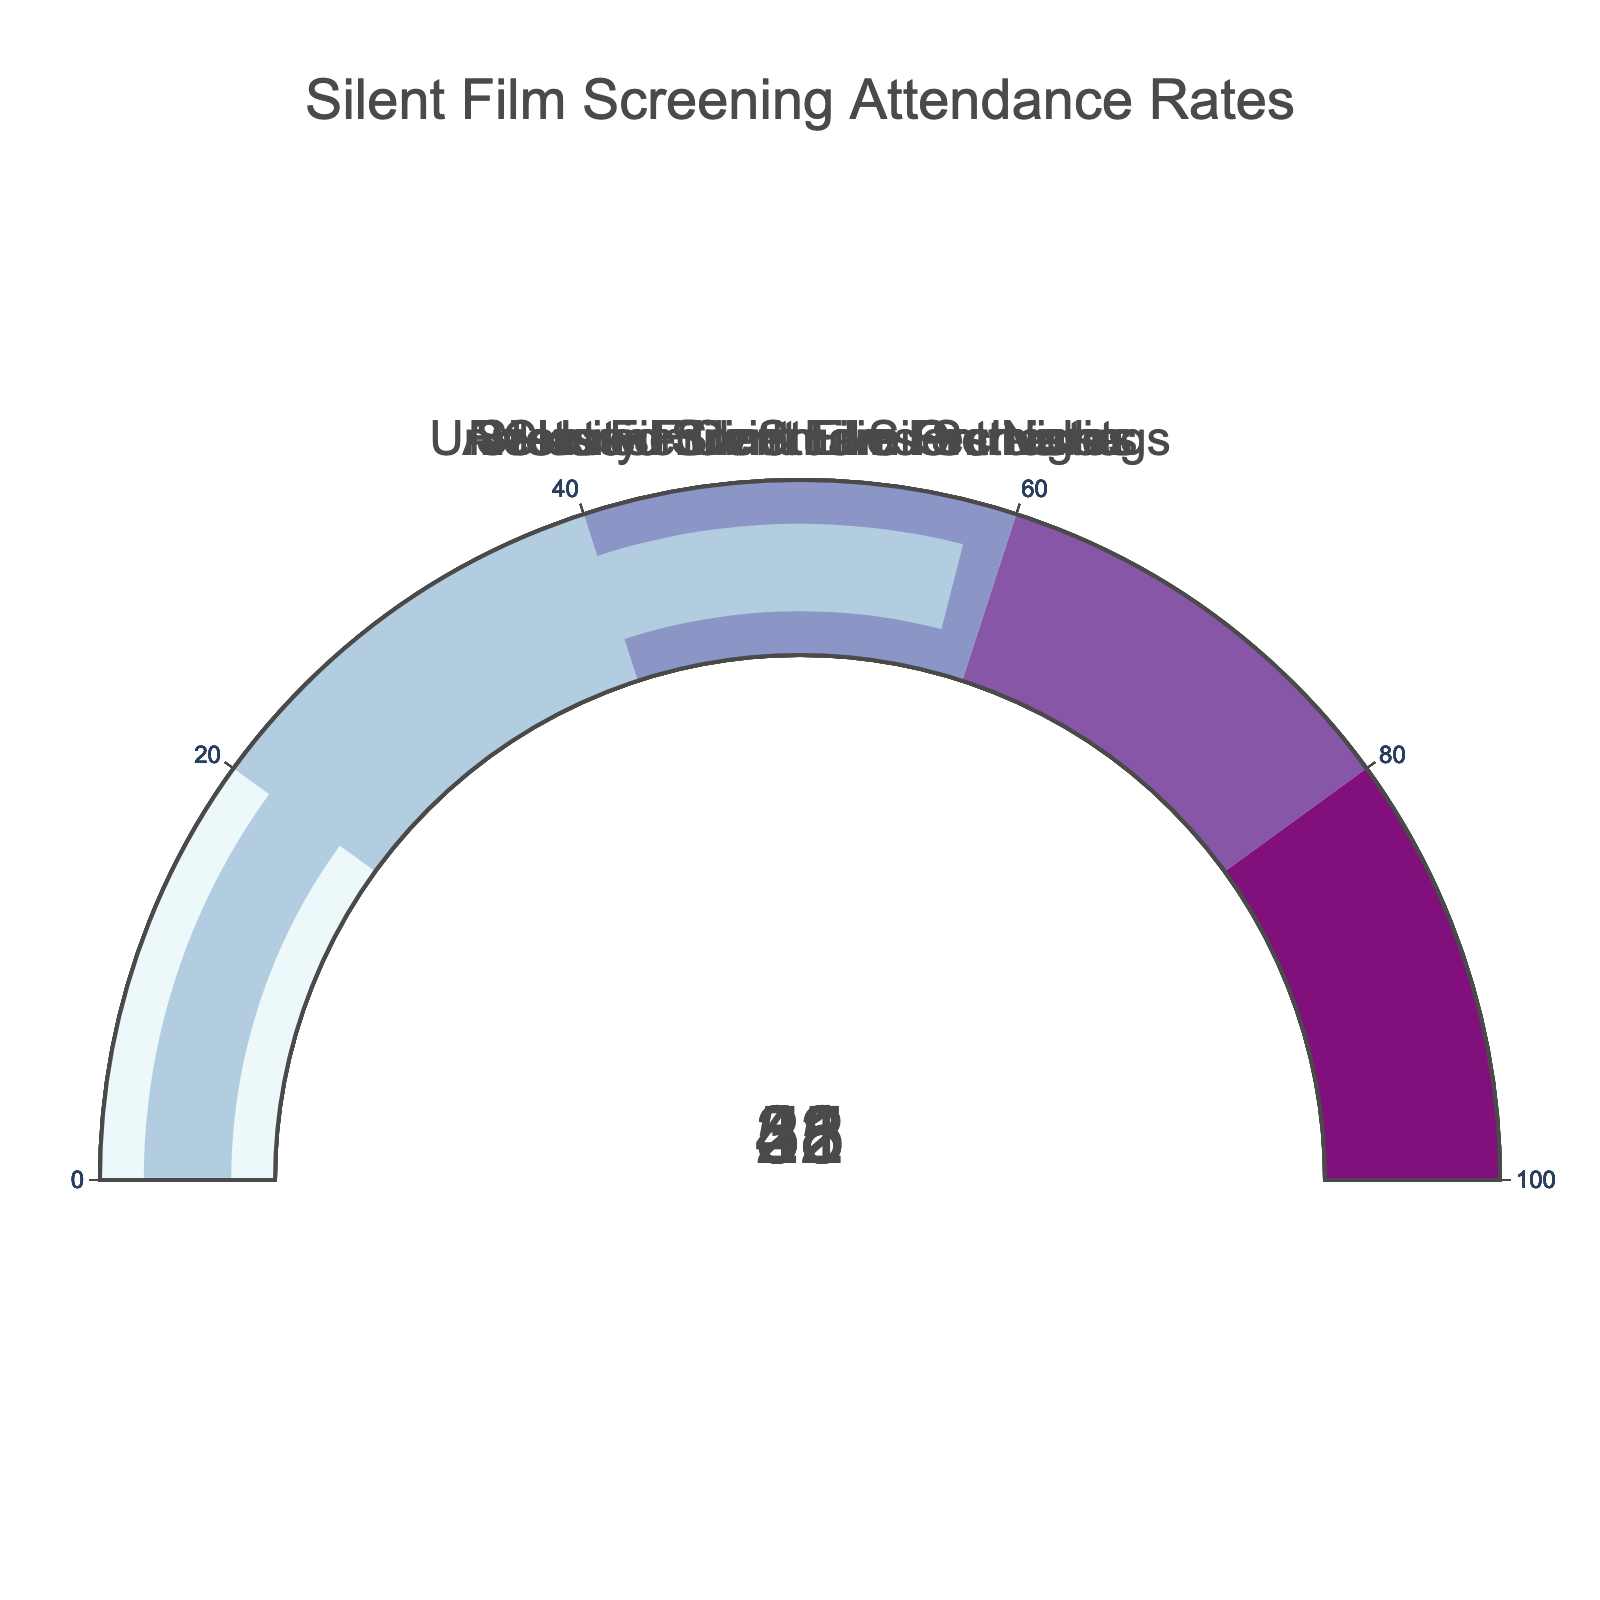What is the range of attendance rates shown in the figure? The range of attendance rates is determined by identifying the minimum and maximum values in the figure. The values are 28, 31, 35, 42, and 58. The range is calculated as maximum value - minimum value: 58 - 28
Answer: 30 Which silent film screening category has the highest attendance rate? By looking at the gauge representing each category, the highest value is 58 for "Silent Film with Live Orchestra".
Answer: Silent Film with Live Orchestra What is the average attendance rate across all categories? To calculate the average, sum all the attendance rates and divide by the number of categories: (35 + 42 + 28 + 31 + 58) / 5. The sum is 194, and the average is 194 / 5
Answer: 38.8 Which two categories have the closest attendance rates? To find the closest attendance rates, compare the differences between each pair of values: the closest are 28 (University Film Studies Screenings) and 31 (Art House Cinema Silent Nights), with a difference of 3.
Answer: University Film Studies Screenings and Art House Cinema Silent Nights What is the difference in attendance rate between the "Restored Silent Film Premieres" and "Classic Silent Film Festivals"? The attendance rate of the "Restored Silent Film Premieres" is 42 and for "Classic Silent Film Festivals" is 35. The difference is 42 - 35.
Answer: 7 Which category has the lowest attendance rate? By inspecting the gauges, the lowest value is 28 for "University Film Studies Screenings".
Answer: University Film Studies Screenings What is the sum of attendance rates for "Classic Silent Film Festivals" and "Art House Cinema Silent Nights"? Summing the values for these two categories: 35 (Classic Silent Film Festivals) + 31 (Art House Cinema Silent Nights).
Answer: 66 If you were to rank the categories by attendance rate, which category would be third highest? First, list the values in descending order: 58, 42, 35, 31, 28. The third highest value corresponds to "Classic Silent Film Festivals".
Answer: Classic Silent Film Festivals 